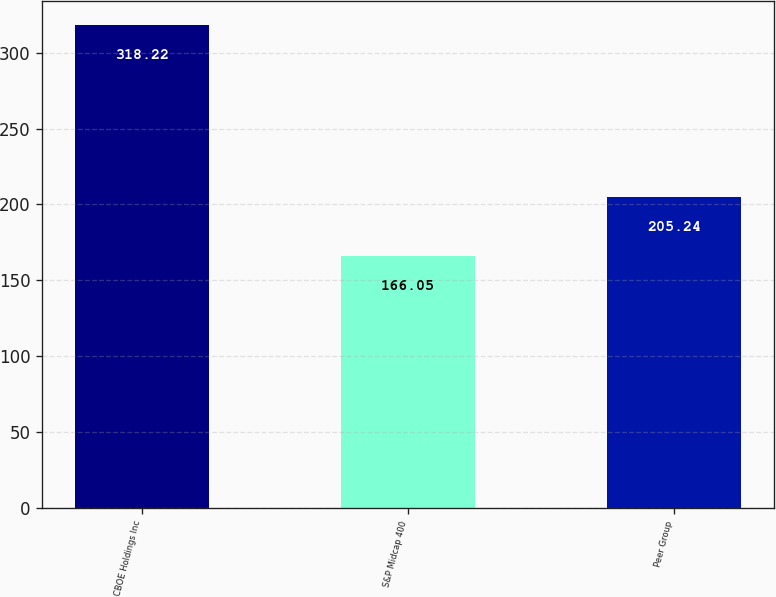<chart> <loc_0><loc_0><loc_500><loc_500><bar_chart><fcel>CBOE Holdings Inc<fcel>S&P Midcap 400<fcel>Peer Group<nl><fcel>318.22<fcel>166.05<fcel>205.24<nl></chart> 